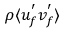<formula> <loc_0><loc_0><loc_500><loc_500>\rho \langle u _ { f } ^ { ^ { \prime } } v _ { f } ^ { ^ { \prime } } \rangle</formula> 